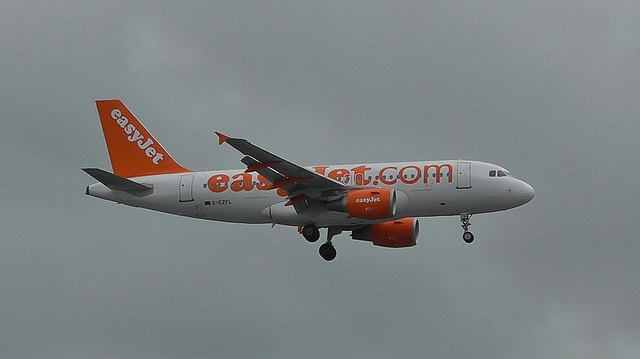Describe the objects in this image and their specific colors. I can see a airplane in darkgray, gray, black, and maroon tones in this image. 